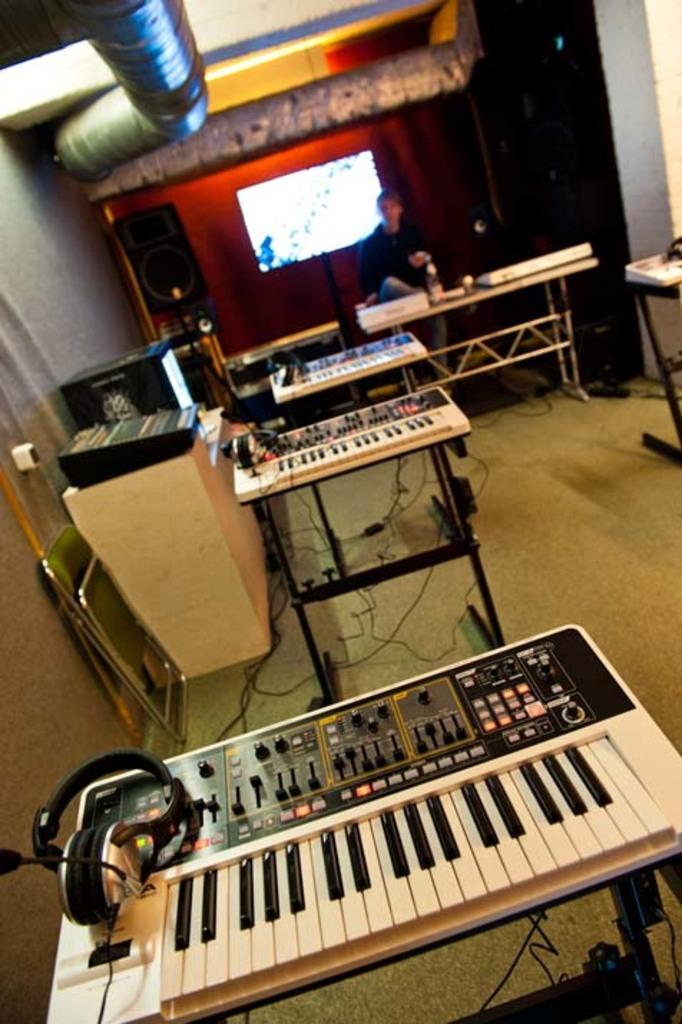What type of objects are present in the image that are related to music? There are musical instruments in the image, including a piano. Can you describe the person in the image? There is a person seated on a chair in the image. What other electronic device is present in the image? A television is present in the image, located behind the person. What type of soda is the person drinking in the image? There is no soda present in the image; the person is seated on a chair and there is a piano and a television visible. Is there a scarecrow in the image? No, there is no scarecrow in the image. 